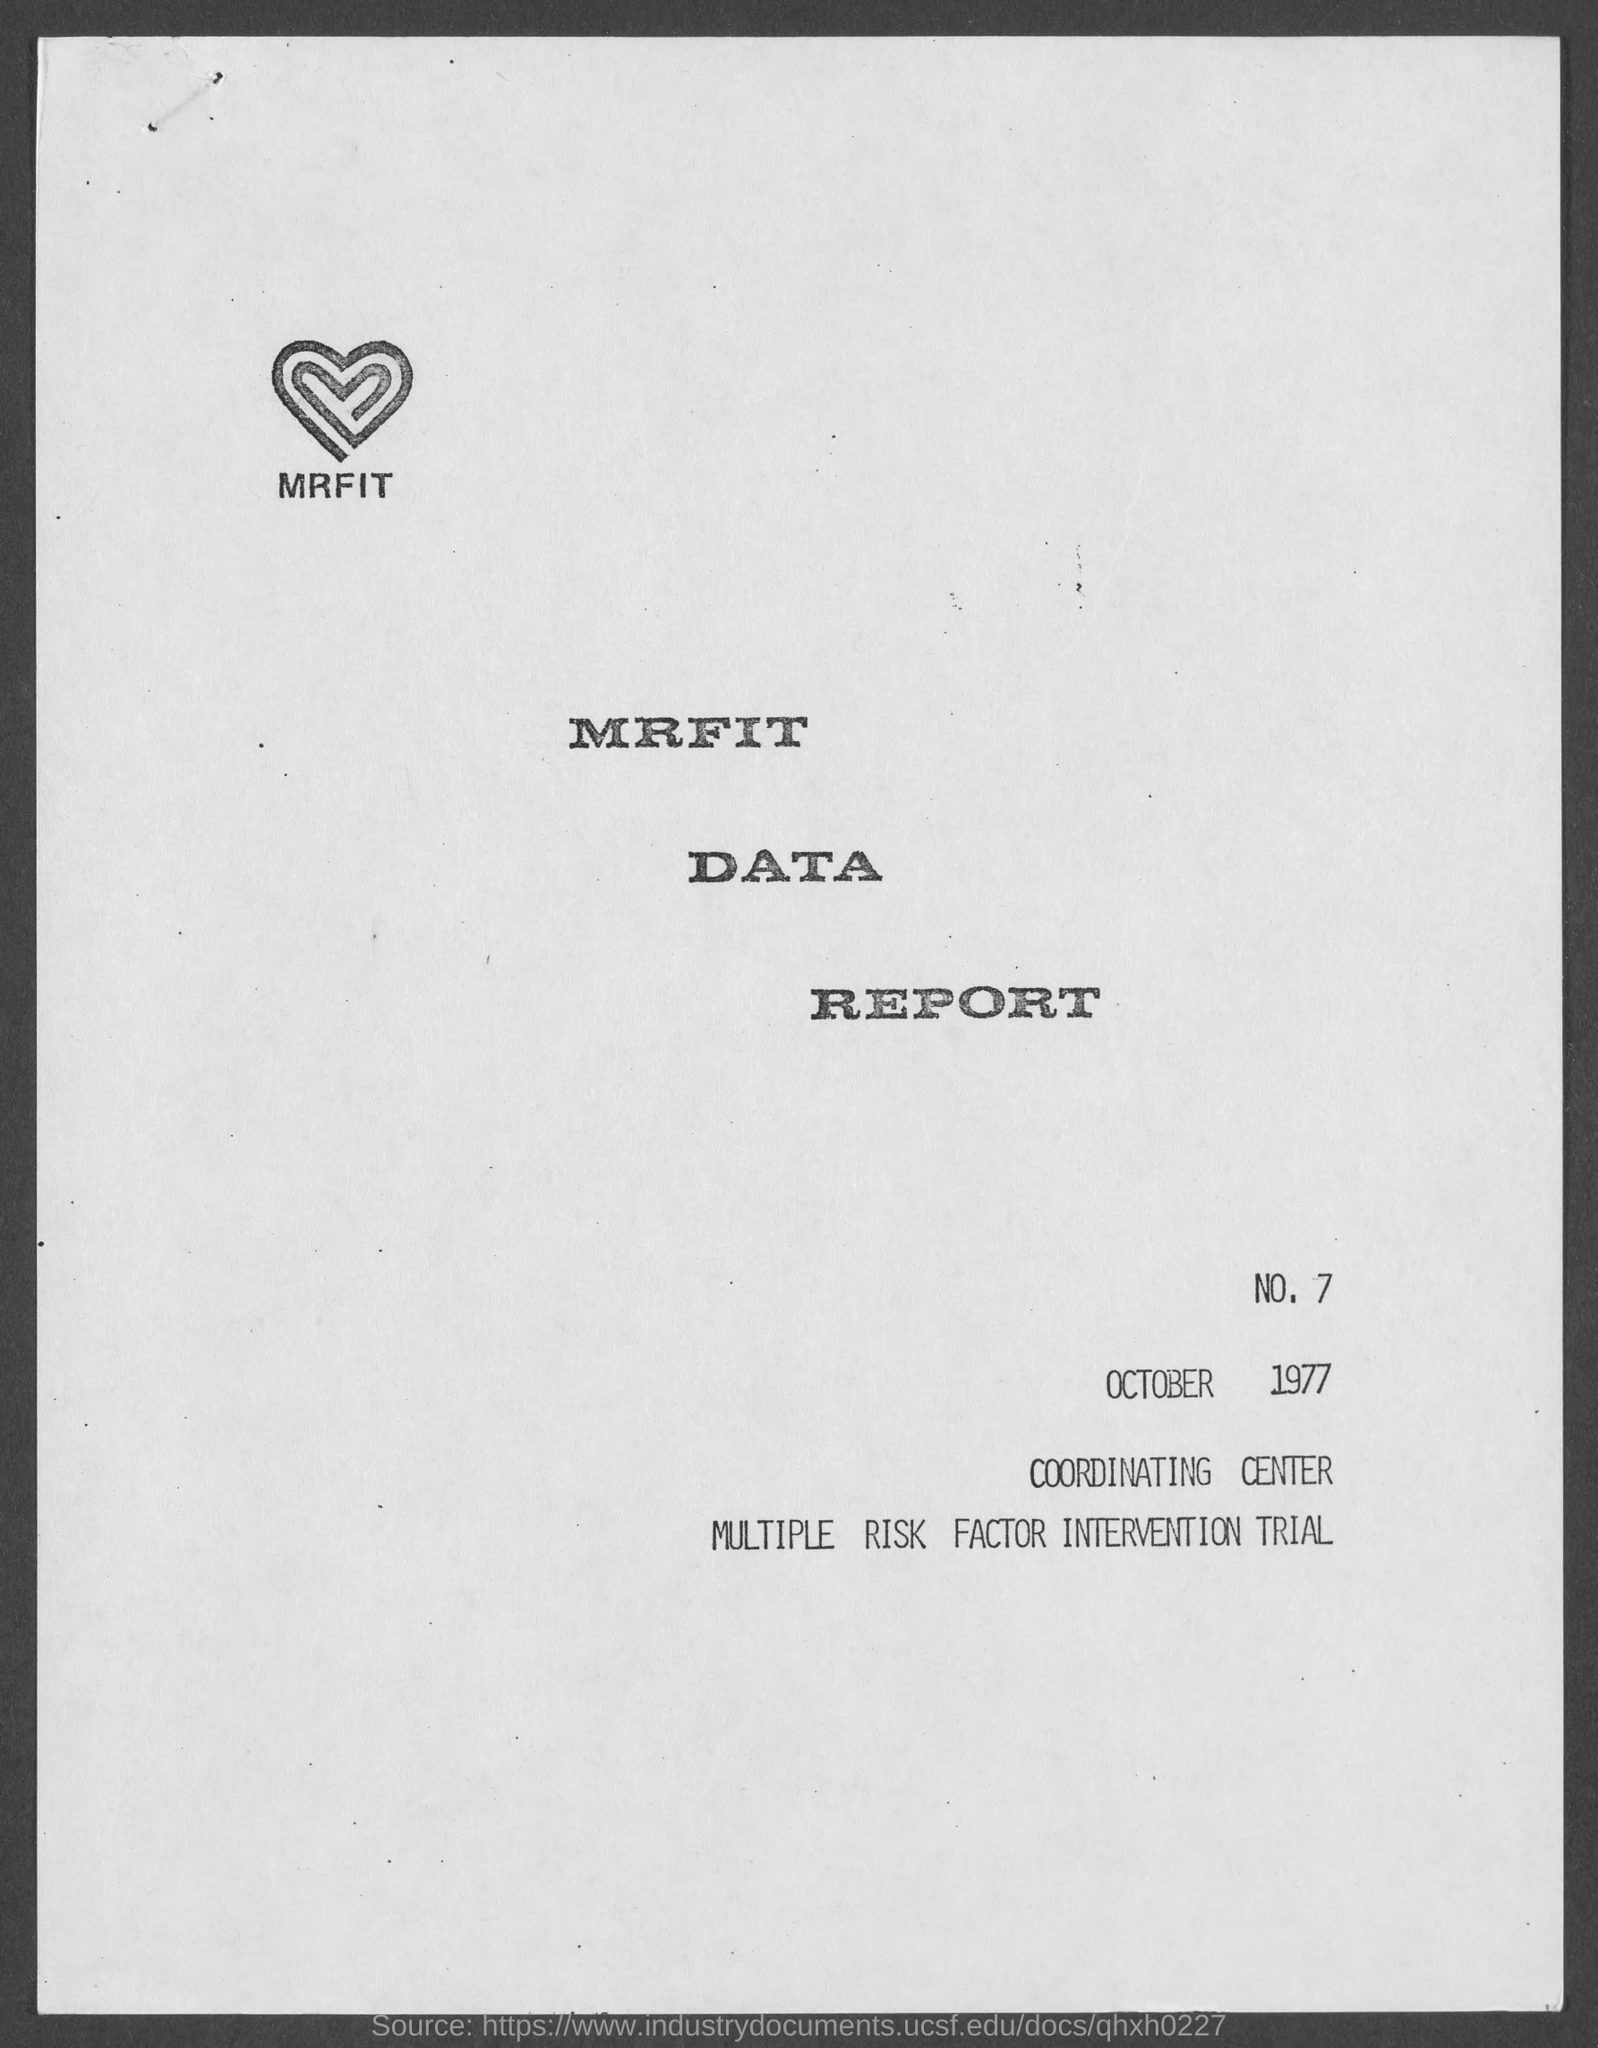What is the date mentioned in this document?
Make the answer very short. October 1977. 